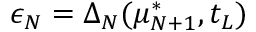<formula> <loc_0><loc_0><loc_500><loc_500>\epsilon _ { N } = \Delta _ { N } ( \mu _ { N + 1 } ^ { * } , t _ { L } )</formula> 